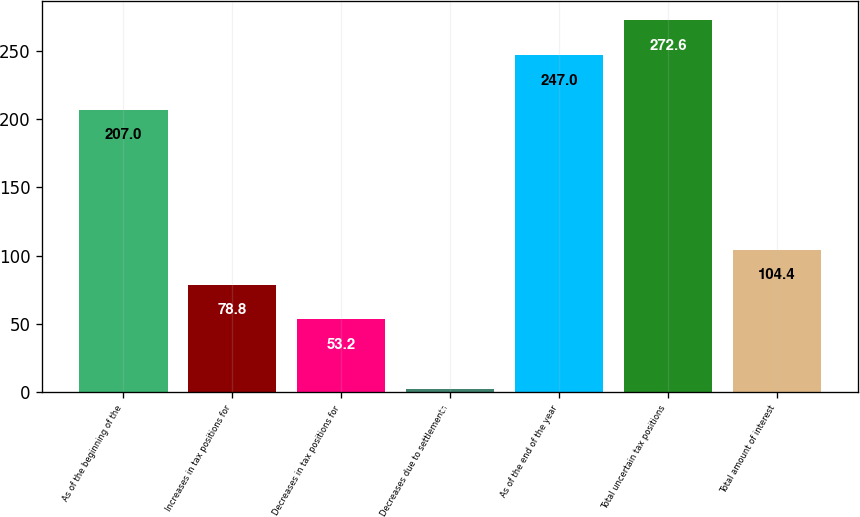Convert chart to OTSL. <chart><loc_0><loc_0><loc_500><loc_500><bar_chart><fcel>As of the beginning of the<fcel>Increases in tax positions for<fcel>Decreases in tax positions for<fcel>Decreases due to settlements<fcel>As of the end of the year<fcel>Total uncertain tax positions<fcel>Total amount of interest<nl><fcel>207<fcel>78.8<fcel>53.2<fcel>2<fcel>247<fcel>272.6<fcel>104.4<nl></chart> 